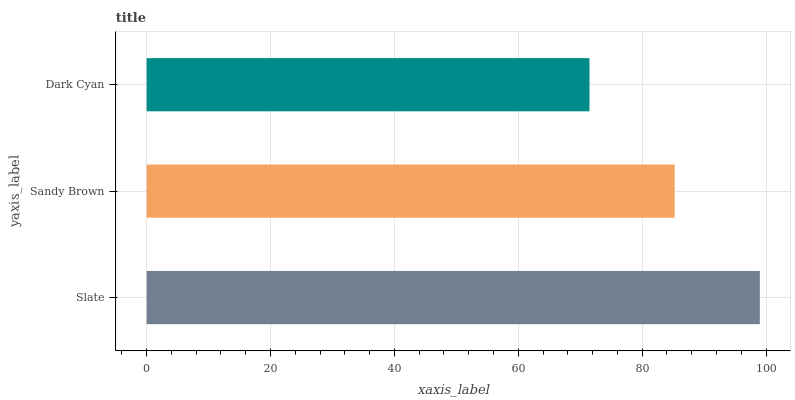Is Dark Cyan the minimum?
Answer yes or no. Yes. Is Slate the maximum?
Answer yes or no. Yes. Is Sandy Brown the minimum?
Answer yes or no. No. Is Sandy Brown the maximum?
Answer yes or no. No. Is Slate greater than Sandy Brown?
Answer yes or no. Yes. Is Sandy Brown less than Slate?
Answer yes or no. Yes. Is Sandy Brown greater than Slate?
Answer yes or no. No. Is Slate less than Sandy Brown?
Answer yes or no. No. Is Sandy Brown the high median?
Answer yes or no. Yes. Is Sandy Brown the low median?
Answer yes or no. Yes. Is Slate the high median?
Answer yes or no. No. Is Dark Cyan the low median?
Answer yes or no. No. 